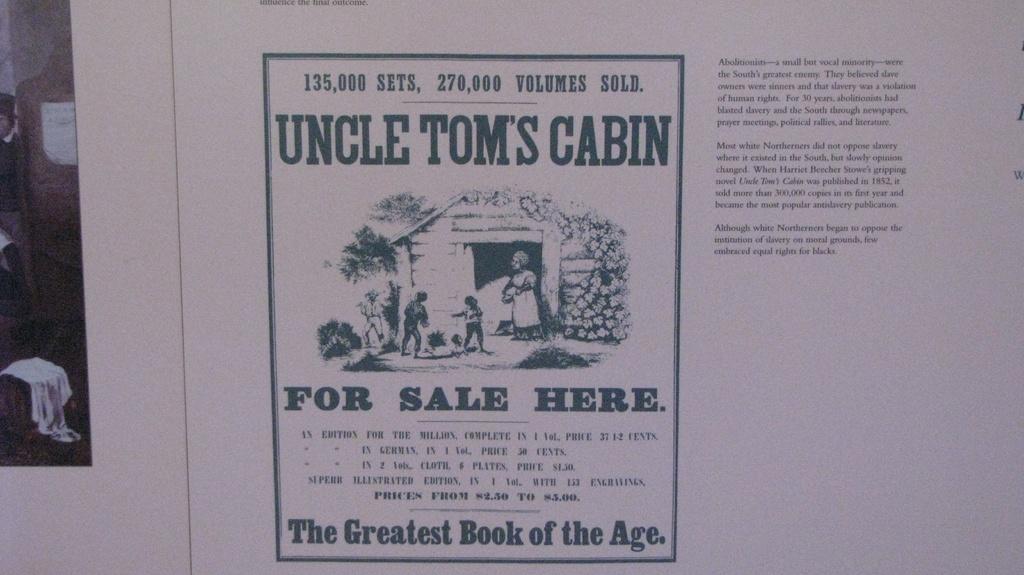How many volumes have been sold?
Your response must be concise. 270,000. What is the greatest book of the age according to this image?
Offer a terse response. Uncle toms cabin. 